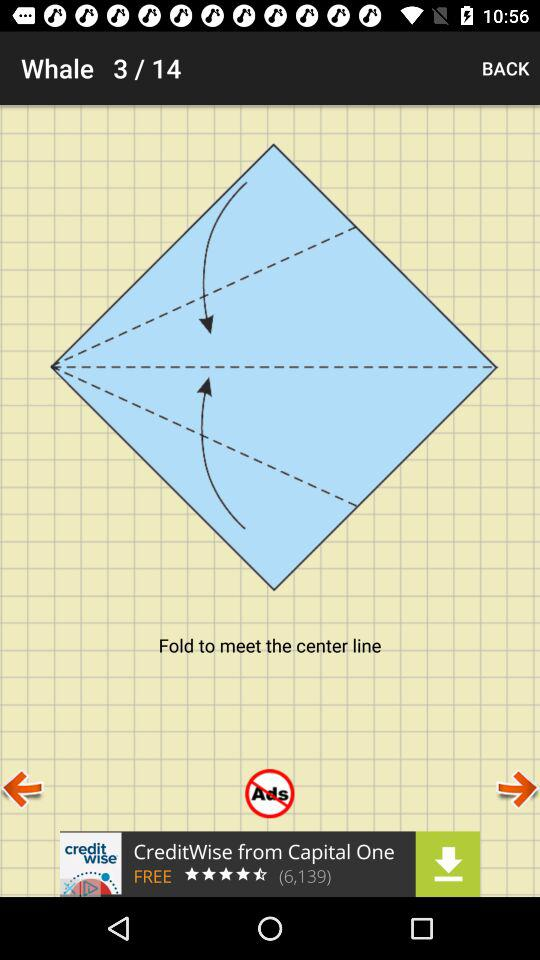What is the total number of slides? The total number of slides is 14. 